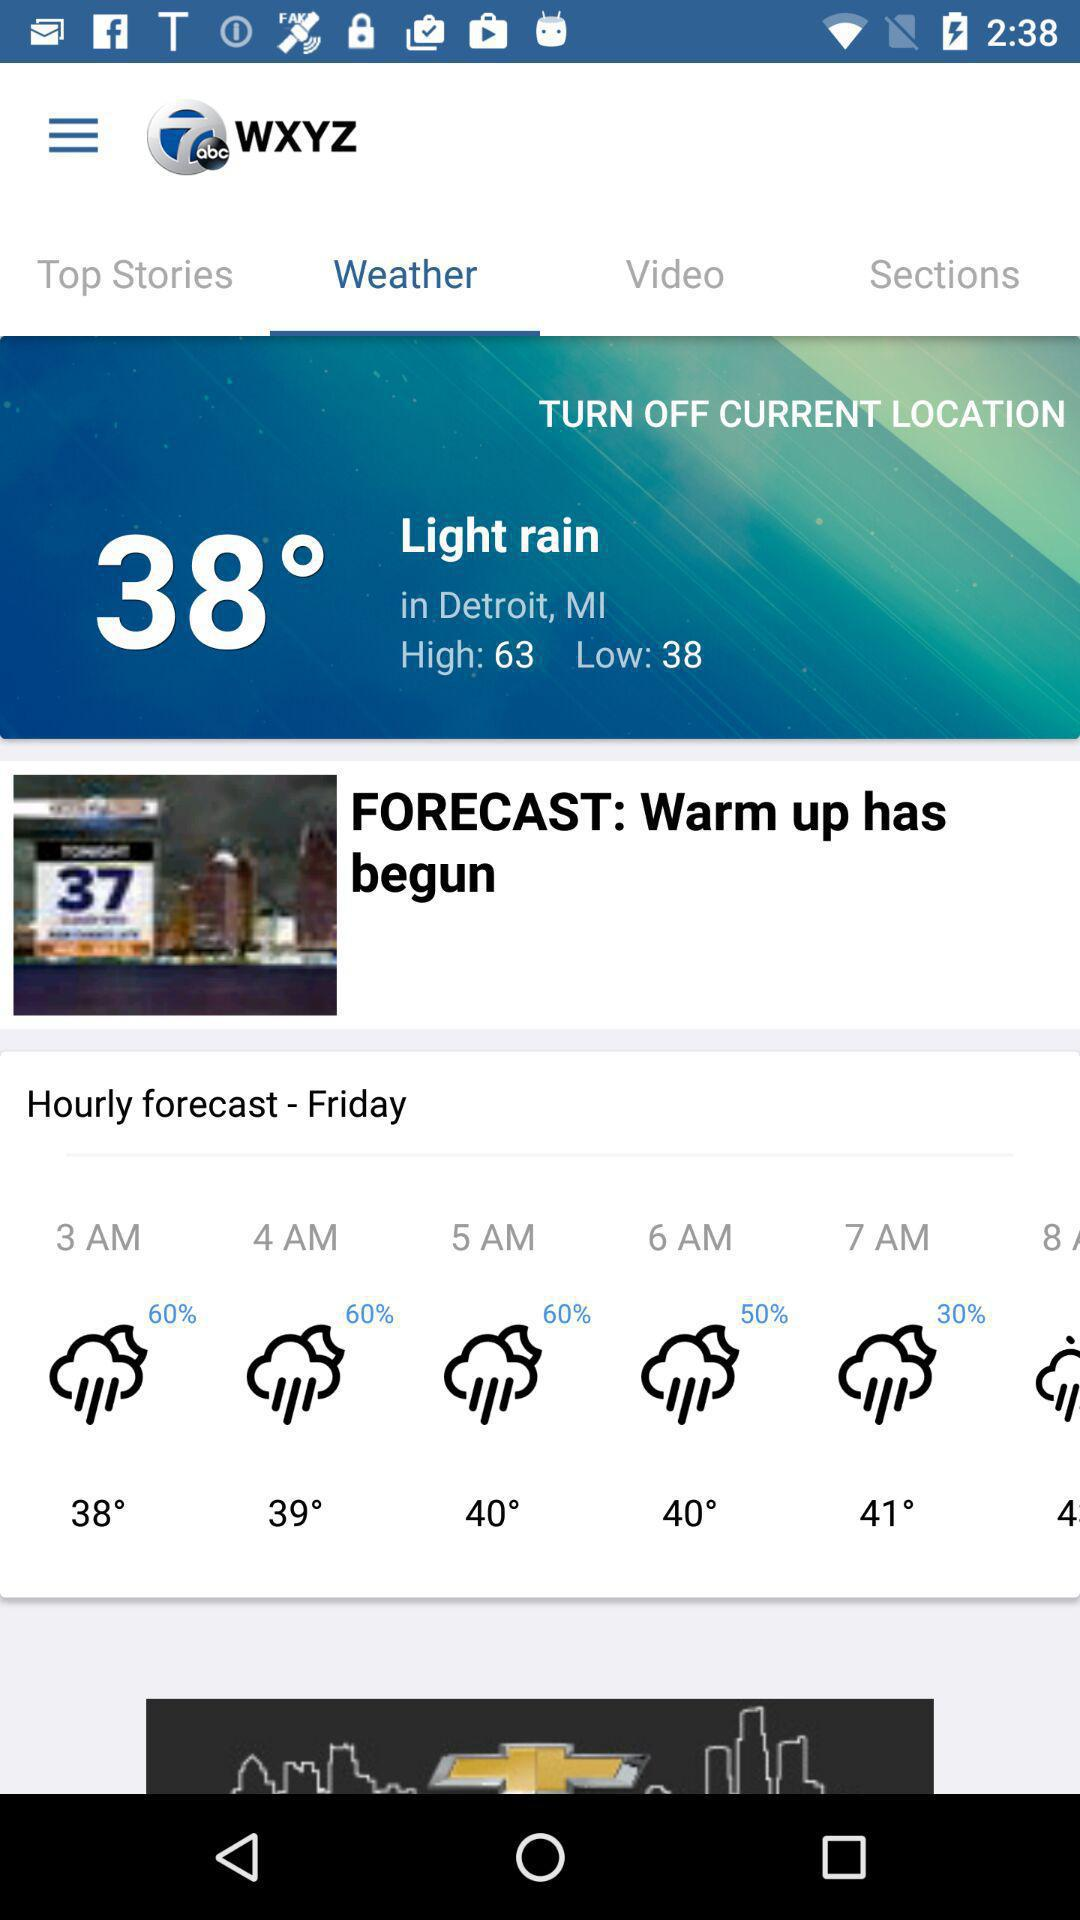What is the weather forecast for Friday? The weather is slightly rainy. 